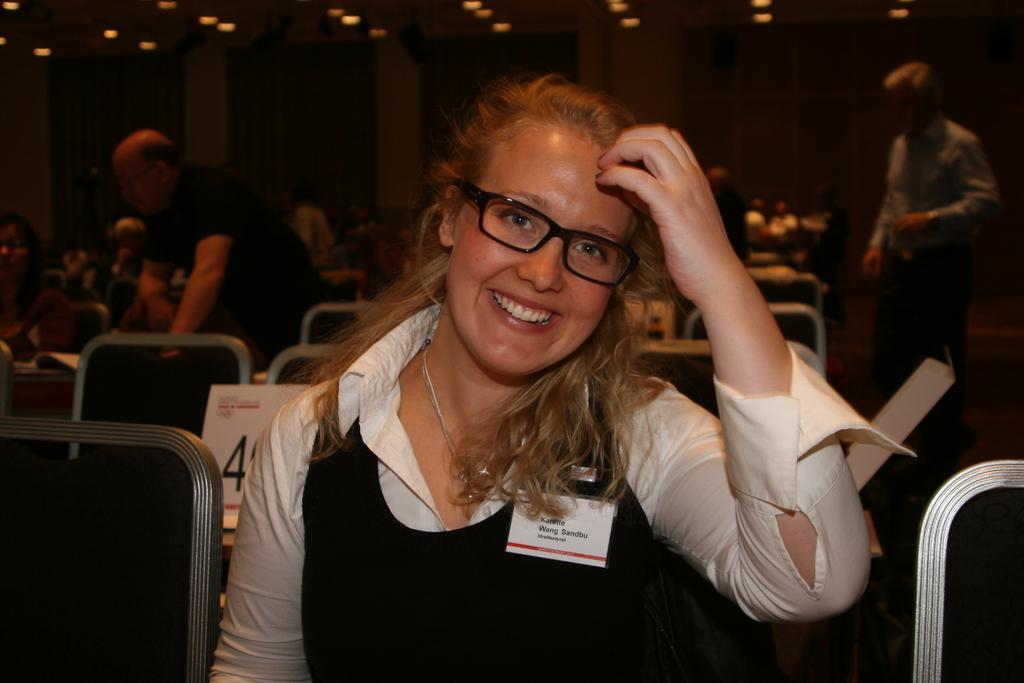What is the main subject of the image? The main subject of the image is a woman. What is the woman wearing in the image? The woman is wearing a black and white dress. What is the woman doing in the image? The woman is sitting and smiling. Can you describe the people in the background of the image? There are persons sitting and standing in the background of the image. What else can be seen in the background of the image? There are lights visible in the background of the image. What is the rate of the arithmetic problem being solved by the woman in the image? There is no arithmetic problem being solved in the image, so there is no rate to determine. What type of art is being created by the woman in the image? The woman is not creating any art in the image; she is simply sitting and smiling. 